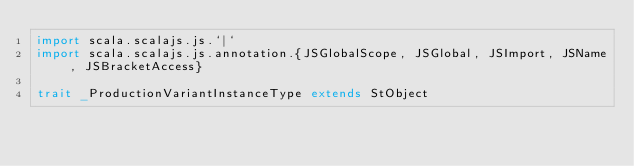Convert code to text. <code><loc_0><loc_0><loc_500><loc_500><_Scala_>import scala.scalajs.js.`|`
import scala.scalajs.js.annotation.{JSGlobalScope, JSGlobal, JSImport, JSName, JSBracketAccess}

trait _ProductionVariantInstanceType extends StObject
</code> 